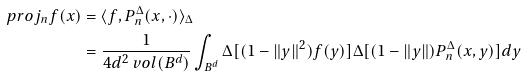Convert formula to latex. <formula><loc_0><loc_0><loc_500><loc_500>\ p r o j _ { n } f ( x ) & = \langle f , P _ { n } ^ { \Delta } ( x , \cdot ) \rangle _ { \Delta } \\ & = \frac { 1 } { 4 d ^ { 2 } \ v o l ( B ^ { d } ) } \int _ { B ^ { d } } \Delta [ ( 1 - \| y \| ^ { 2 } ) f ( y ) ] \Delta [ ( 1 - \| y \| ) P _ { n } ^ { \Delta } ( x , y ) ] d y</formula> 